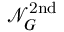<formula> <loc_0><loc_0><loc_500><loc_500>\mathcal { N } _ { G } ^ { 2 n d }</formula> 